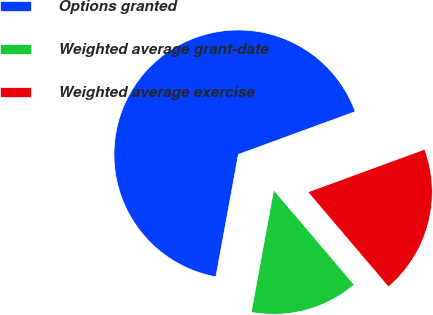Convert chart. <chart><loc_0><loc_0><loc_500><loc_500><pie_chart><fcel>Options granted<fcel>Weighted average grant-date<fcel>Weighted average exercise<nl><fcel>66.52%<fcel>14.1%<fcel>19.38%<nl></chart> 